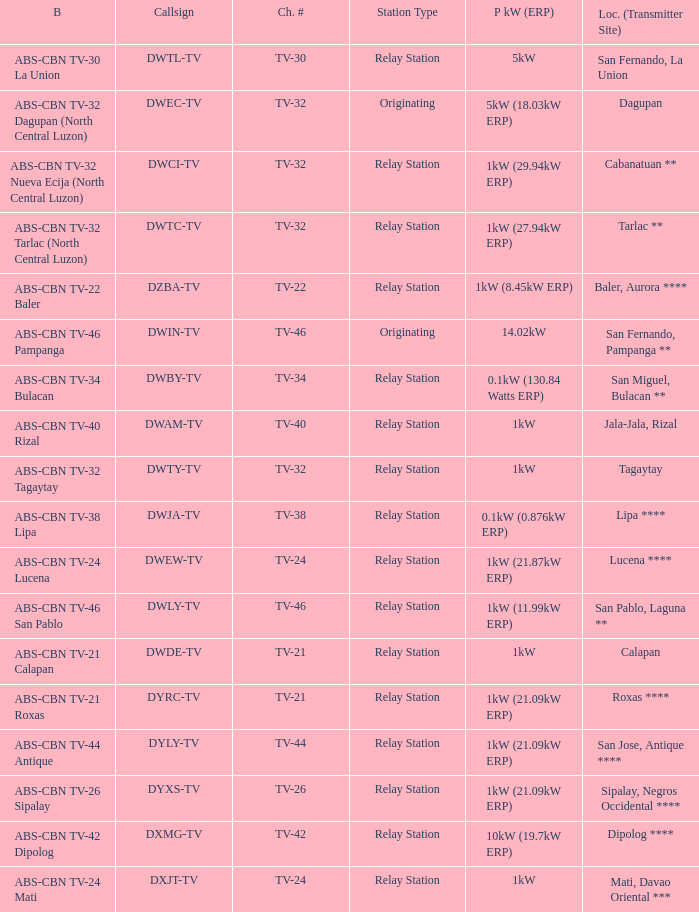How many brandings are there where the Power kW (ERP) is 1kW (29.94kW ERP)? 1.0. 